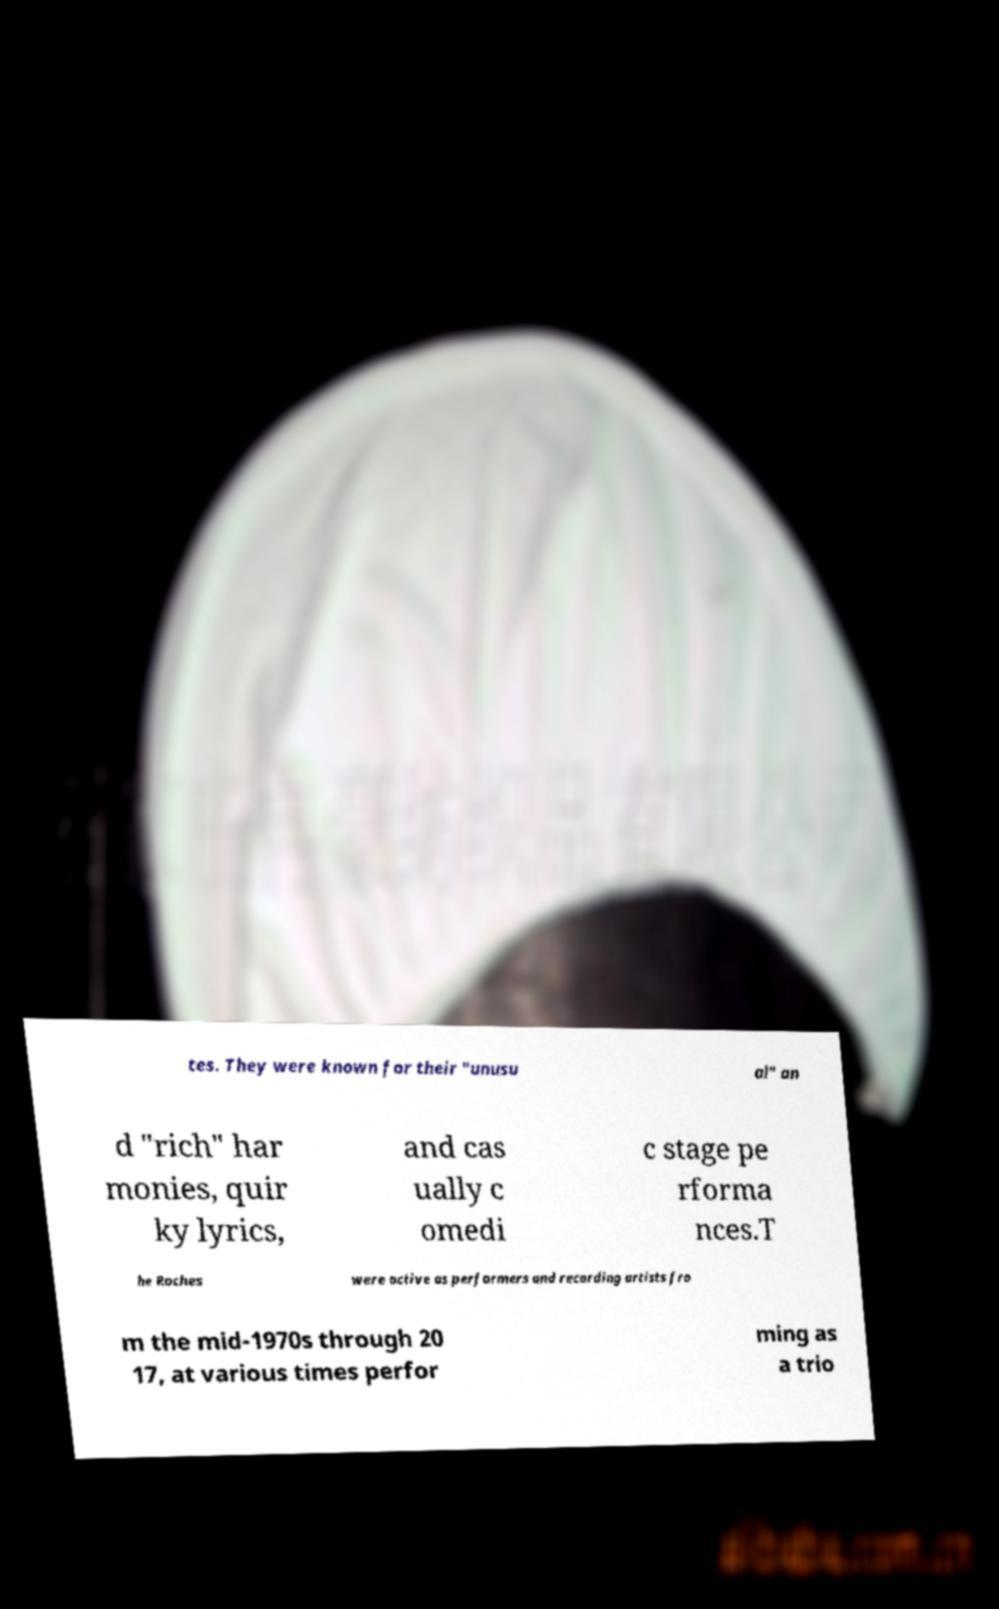For documentation purposes, I need the text within this image transcribed. Could you provide that? tes. They were known for their "unusu al" an d "rich" har monies, quir ky lyrics, and cas ually c omedi c stage pe rforma nces.T he Roches were active as performers and recording artists fro m the mid-1970s through 20 17, at various times perfor ming as a trio 